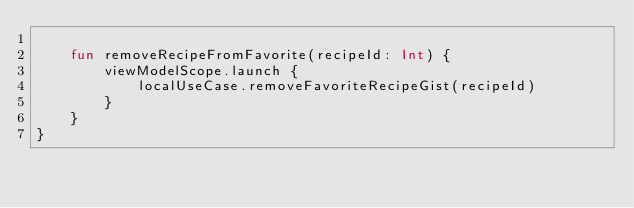Convert code to text. <code><loc_0><loc_0><loc_500><loc_500><_Kotlin_>
    fun removeRecipeFromFavorite(recipeId: Int) {
        viewModelScope.launch {
            localUseCase.removeFavoriteRecipeGist(recipeId)
        }
    }
}</code> 